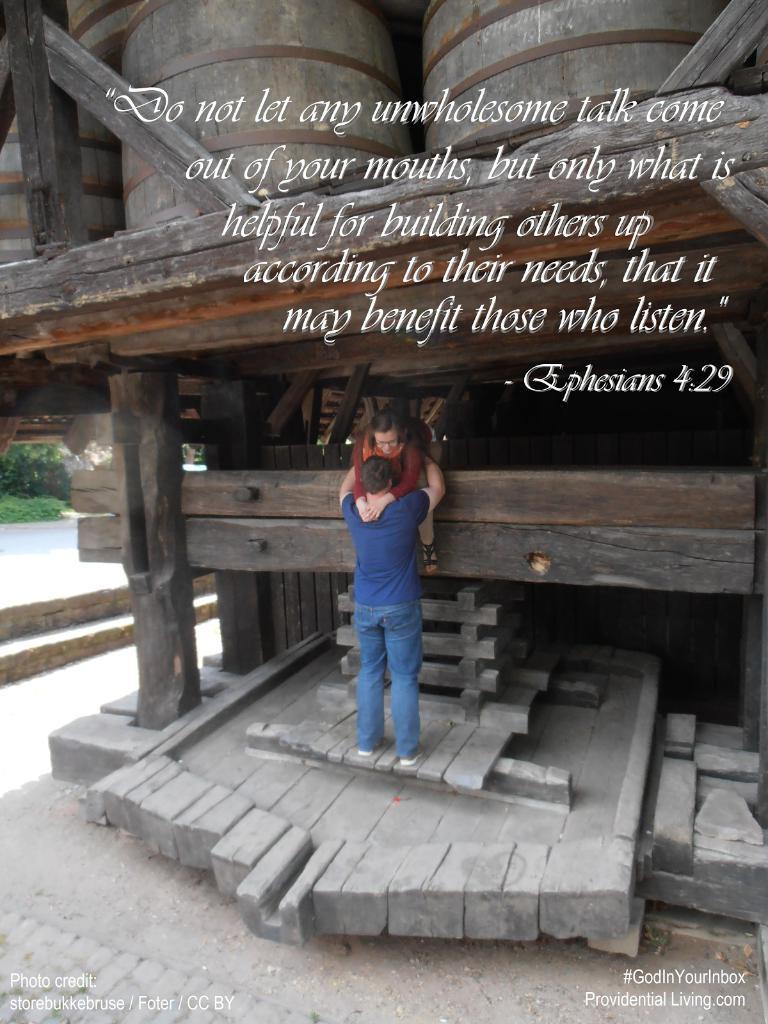Please provide a concise description of this image. In this image I can see two persons, I can see one is wearing brown colour dress and one is wearing blue. I can also see something is written over here. 